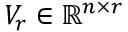Convert formula to latex. <formula><loc_0><loc_0><loc_500><loc_500>V _ { r } \in { \mathbb { R } } ^ { n \times r }</formula> 